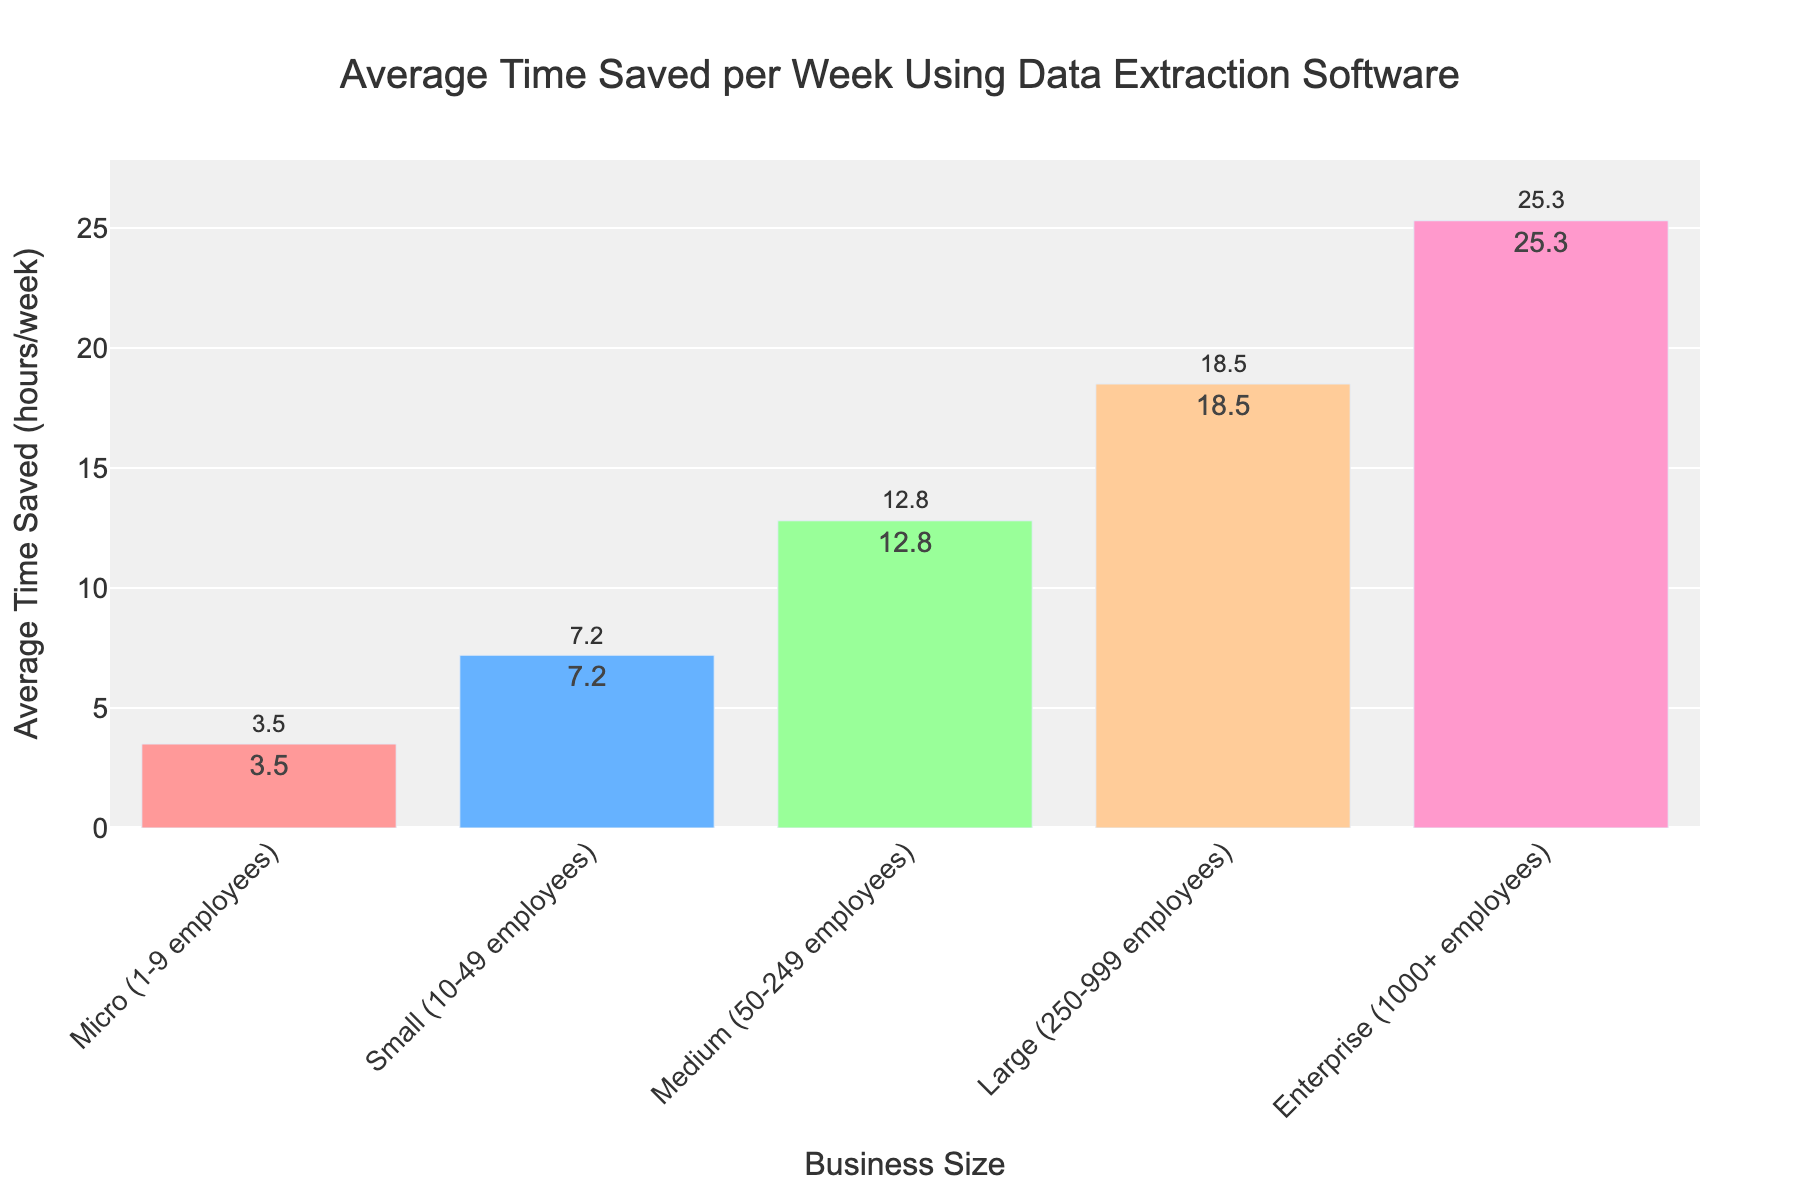What's the average time saved per week by businesses with 50-999 employees? To find this, we need to calculate the average time saved for Medium (12.8 hours) and Large (18.5 hours) business sizes. Add these two values together and divide by 2: (12.8 + 18.5) / 2 = 15.65 hours.
Answer: 15.65 hours Which business size saves the most time per week? By examining the height of the bars and the text labels on the chart, the Enterprise (1000+ employees) business size saves the most time with 25.3 hours per week.
Answer: Enterprise (1000+ employees) Compare the time saved between Micro and Small businesses. How much more time do Small businesses save on average per week? First, identify the average time saved for Micro (3.5 hours) and Small (7.2 hours) business sizes. Calculate the difference: 7.2 - 3.5 = 3.7 hours.
Answer: 3.7 hours What's the total average time saved per week by all business sizes combined? Add all the average times saved per week to find the total: 3.5 + 7.2 + 12.8 + 18.5 + 25.3 = 67.3 hours.
Answer: 67.3 hours Which business sizes save more than 10 hours per week on average? By checking the bars and their associated text values, Medium (12.8 hours), Large (18.5 hours), and Enterprise (25.3 hours) all save more than 10 hours per week.
Answer: Medium, Large, Enterprise Is there a greater difference in time saved between Small and Medium businesses or Medium and Large businesses? Calculate the differences: Small to Medium (12.8 - 7.2 = 5.6 hours) and Medium to Large (18.5 - 12.8 = 5.7 hours). The latter has a slightly greater difference.
Answer: Medium and Large Do Micro businesses save less than half the time compared to Large businesses? First, find half the time saved by Large businesses: 18.5 / 2 = 9.25 hours. Then compare this to the time saved by Micro businesses (3.5 hours). Yes, 3.5 is less than 9.25.
Answer: Yes What color is the bar representing Medium business size? By looking at the chart, the bar representing Medium (50-249 employees) business size is green.
Answer: Green Among the listed business sizes, which one saves the second least amount of time on average? The bars show that Micro businesses save the least time (3.5 hours), and Small businesses save the next least (7.2 hours).
Answer: Small What's the average increase in time saved as business size increases from Micro to Enterprise? Calculate the average increase per category: [(7.2-3.5) + (12.8-7.2) + (18.5-12.8) + (25.3-18.5)] / 4 = 4.45 hours.
Answer: 4.45 hours 